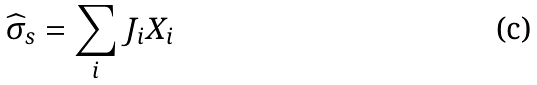<formula> <loc_0><loc_0><loc_500><loc_500>\widehat { \sigma } _ { s } = \sum _ { i } { J _ { i } X _ { i } }</formula> 